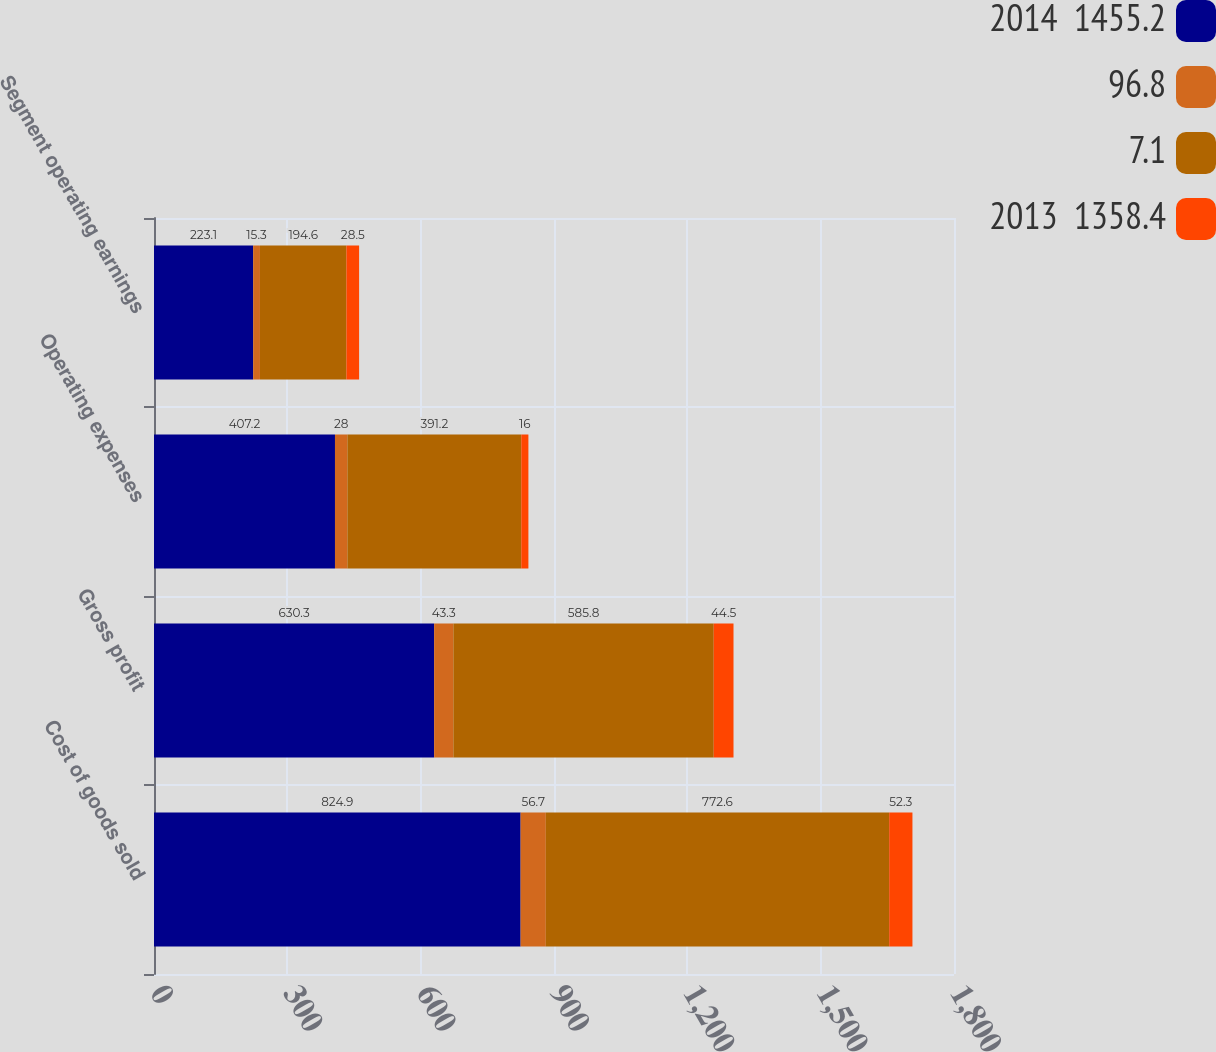<chart> <loc_0><loc_0><loc_500><loc_500><stacked_bar_chart><ecel><fcel>Cost of goods sold<fcel>Gross profit<fcel>Operating expenses<fcel>Segment operating earnings<nl><fcel>2014  1455.2<fcel>824.9<fcel>630.3<fcel>407.2<fcel>223.1<nl><fcel>96.8<fcel>56.7<fcel>43.3<fcel>28<fcel>15.3<nl><fcel>7.1<fcel>772.6<fcel>585.8<fcel>391.2<fcel>194.6<nl><fcel>2013  1358.4<fcel>52.3<fcel>44.5<fcel>16<fcel>28.5<nl></chart> 